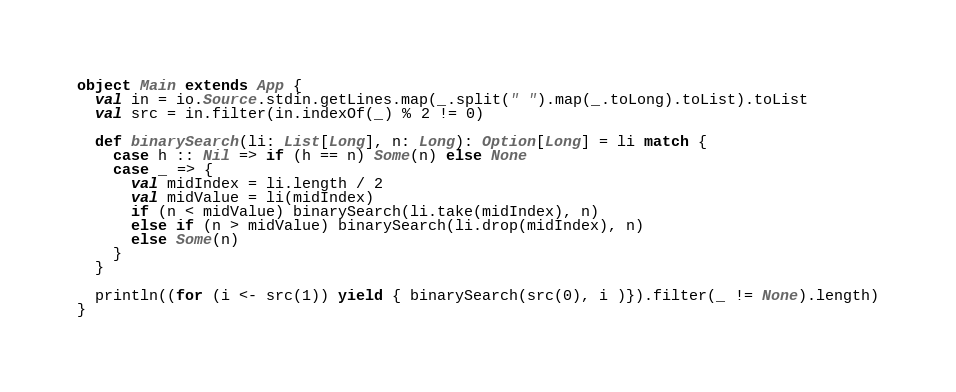<code> <loc_0><loc_0><loc_500><loc_500><_Scala_>object Main extends App {
  val in = io.Source.stdin.getLines.map(_.split(" ").map(_.toLong).toList).toList
  val src = in.filter(in.indexOf(_) % 2 != 0)

  def binarySearch(li: List[Long], n: Long): Option[Long] = li match {
    case h :: Nil => if (h == n) Some(n) else None
    case _ => {
      val midIndex = li.length / 2
      val midValue = li(midIndex)
      if (n < midValue) binarySearch(li.take(midIndex), n)
      else if (n > midValue) binarySearch(li.drop(midIndex), n)
      else Some(n)
    }
  }

  println((for (i <- src(1)) yield { binarySearch(src(0), i )}).filter(_ != None).length)
}</code> 